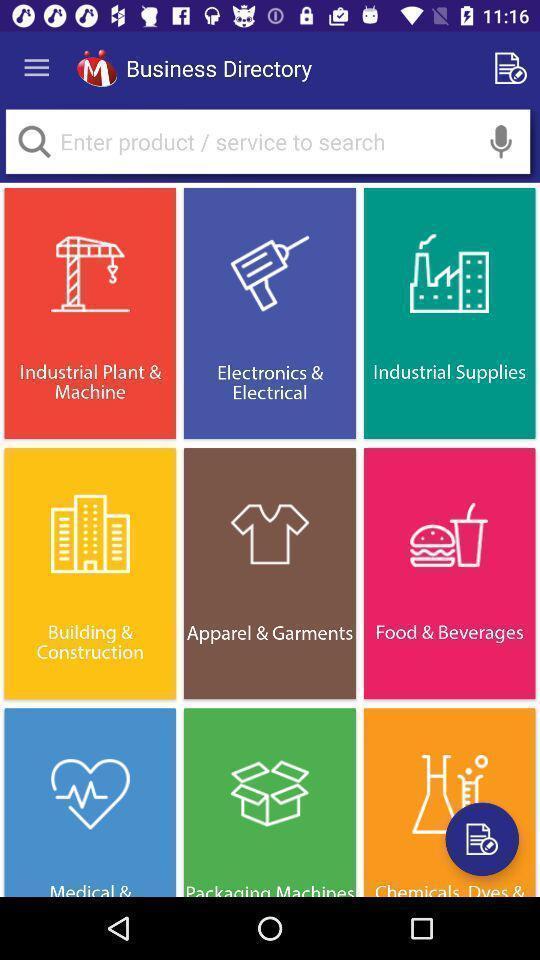What details can you identify in this image? Screen displaying different types of business. 